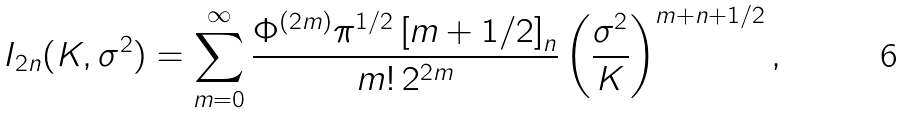<formula> <loc_0><loc_0><loc_500><loc_500>I _ { 2 n } ( K , \sigma ^ { 2 } ) = \sum _ { m = 0 } ^ { \infty } \frac { \Phi ^ { ( 2 m ) } \pi ^ { 1 / 2 } \left [ m + 1 / 2 \right ] _ { n } } { m ! \, 2 ^ { 2 m } } \left ( \frac { \sigma ^ { 2 } } { K } \right ) ^ { m + n + 1 / 2 } ,</formula> 